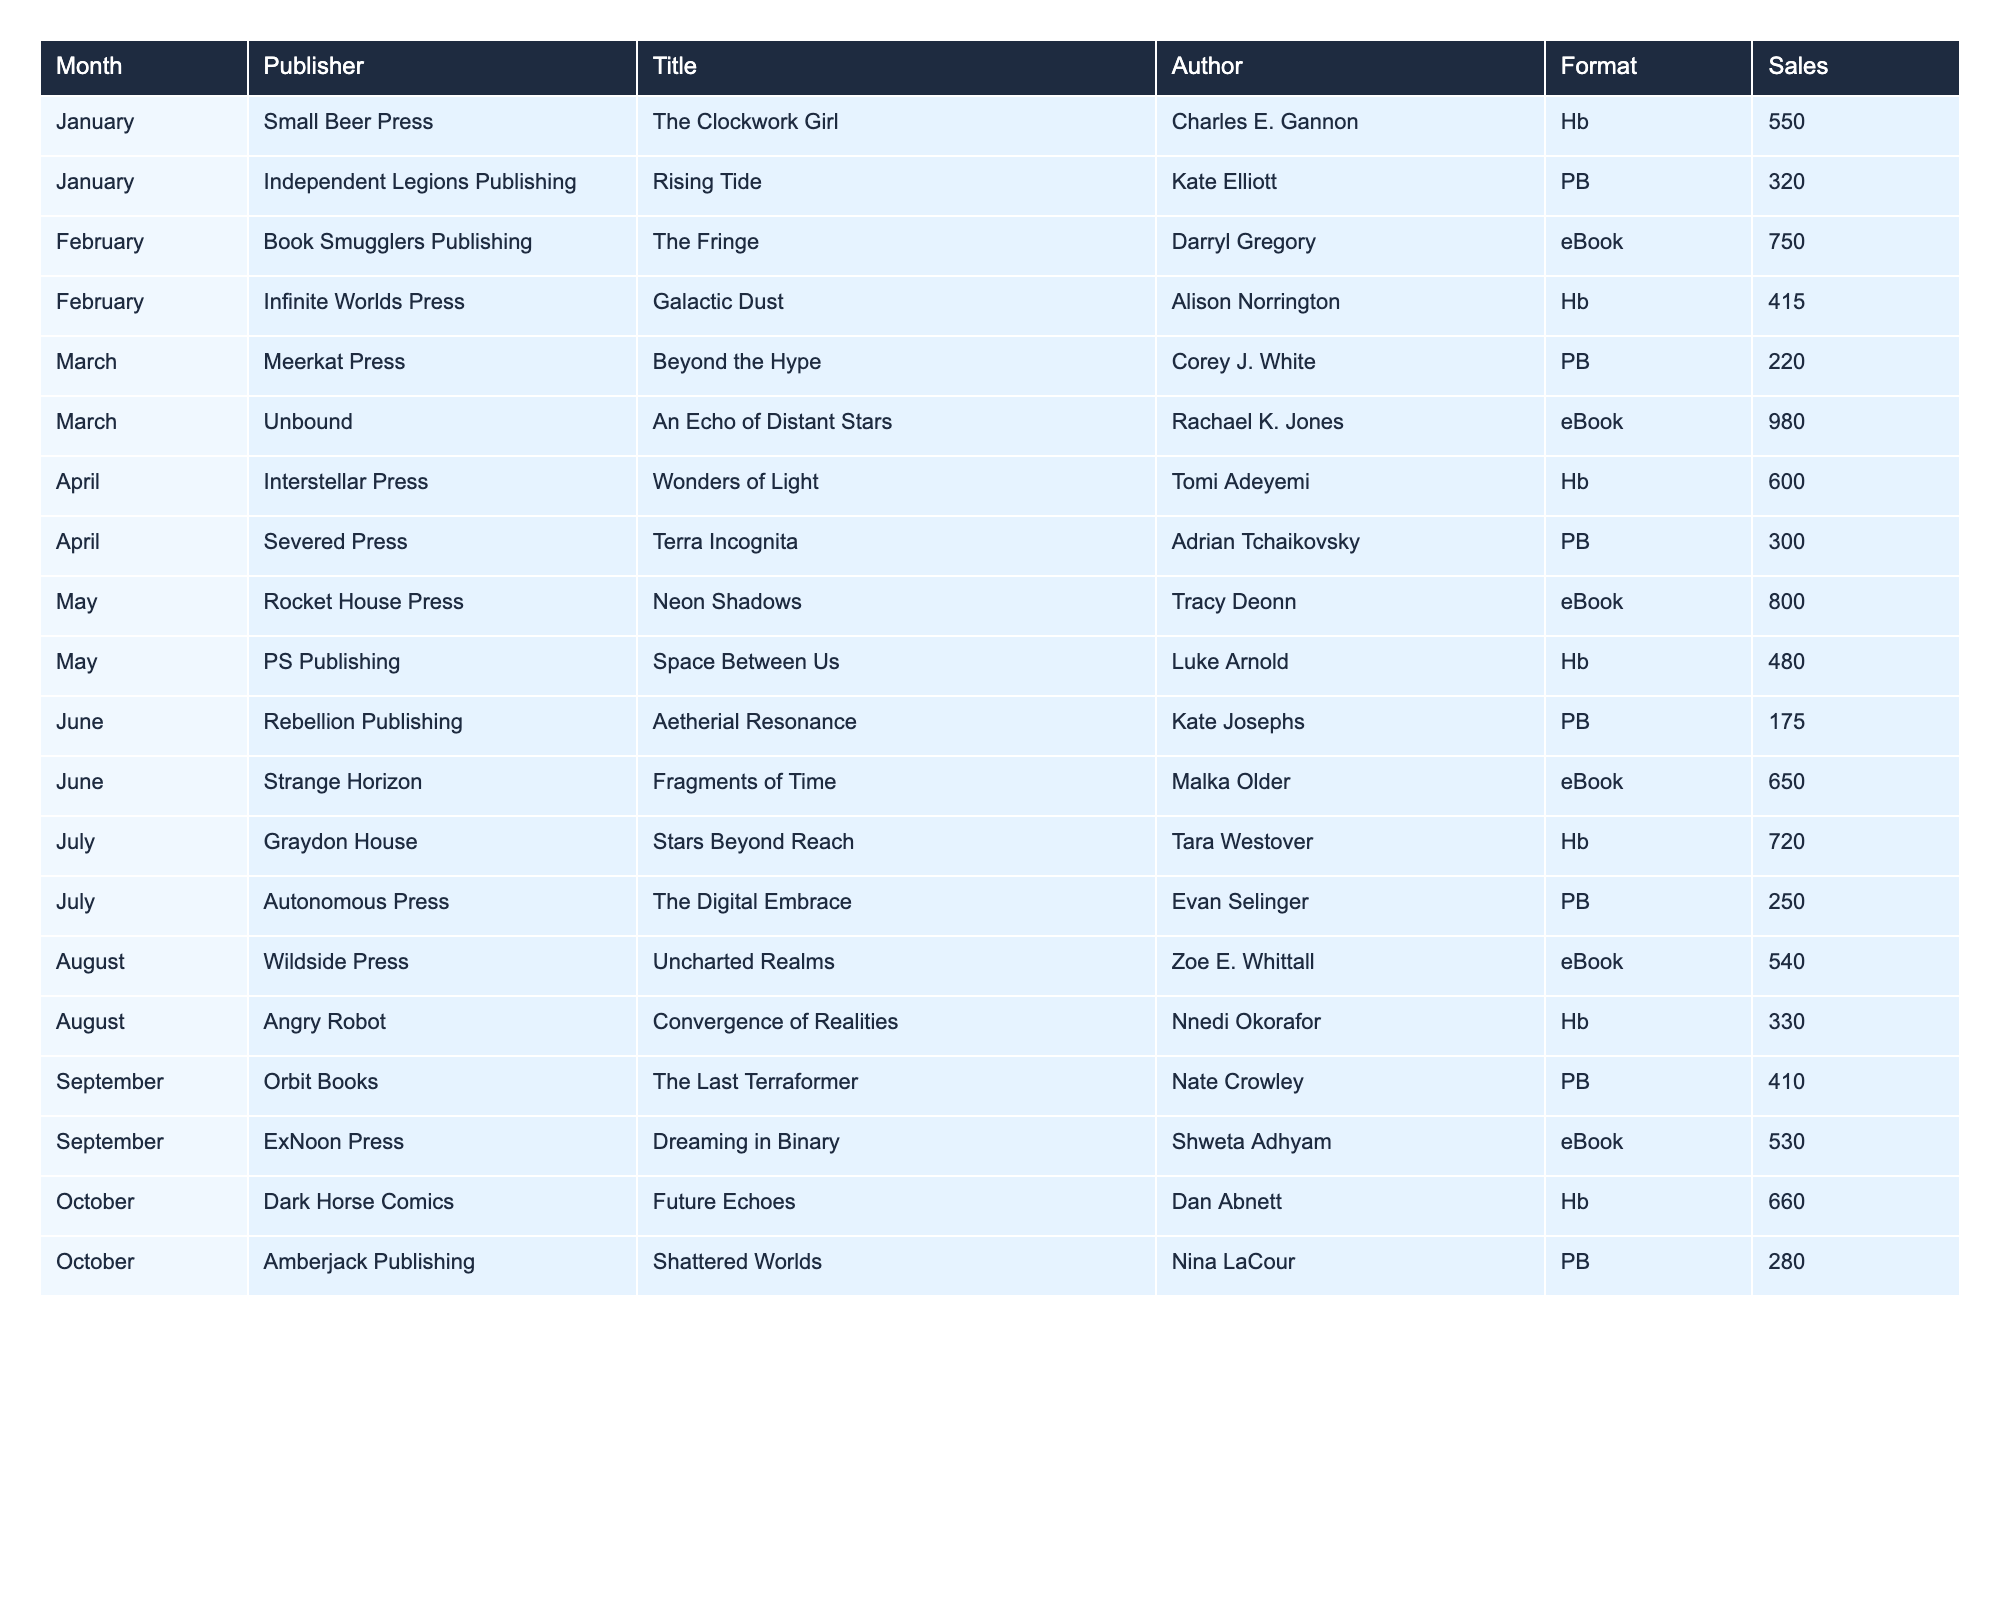What is the highest sales figure recorded in the table? The highest sales figure is 980, which corresponds to the eBook title "An Echo of Distant Stars" by Rachael K. Jones published by Unbound in March.
Answer: 980 Which month had the lowest total sales among its titles? To find the month with the lowest total sales, calculate the sales for each month: January (870), February (1165), March (1200), April (900), May (1280), June (825), July (970), August (870), September (940), October (940). The month with the lowest sales is June with a total of 825.
Answer: June Which publisher released the most titles in the data set? By reviewing the table, we can see that each publisher only released one title. Therefore, no publisher released more than one title.
Answer: No publisher released more than one title What is the average sales for eBooks in the table? There are 5 eBook titles with sales figures of 750, 980, 800, 650, and 530. First, sum these sales (750 + 980 + 800 + 650 + 530 = 3710), then divide by the number of eBooks (3710 / 5 = 742).
Answer: 742 Is there a title with sales greater than 700 for more than one publication format? There is only one title with sales for multiple formats, but it is the same title. "The Digital Embrace" has different formats but does not have sales greater than 700. Therefore, this is false.
Answer: No What is the total sales for titles released in April and May combined? The sales for April are 600 (Wonders of Light) + 300 (Terra Incognita) = 900, and for May it is 800 (Neon Shadows) + 480 (Space Between Us) = 1280. The combined total is 900 + 1280 = 2180.
Answer: 2180 Which author had the lowest sales for their title? From reviewing the sales figures, Malka Older with "Fragments of Time" had the lowest sales at 175.
Answer: Malka Older What percentage of total sales does the eBook format represent in the entire data set? The total sales figures for all formats are: 550 + 320 + 750 + 415 + 220 + 980 + 600 + 300 + 800 + 480 + 175 + 650 + 720 + 250 + 540 + 330 + 410 + 530 + 660 + 280 = 10295. The sales for eBooks are 750 + 980 + 800 + 650 + 530 = 3710. The percentage is therefore (3710 / 10295) * 100 = 36.1%.
Answer: 36.1% Which title had the second-highest sales in the entire table? Listing the sales in descending order: 980 (An Echo of Distant Stars), 800 (Neon Shadows), 750 (The Fringe), 720 (Stars Beyond Reach), and 660 (Future Echoes). Therefore, the second-highest sales are 800.
Answer: 800 